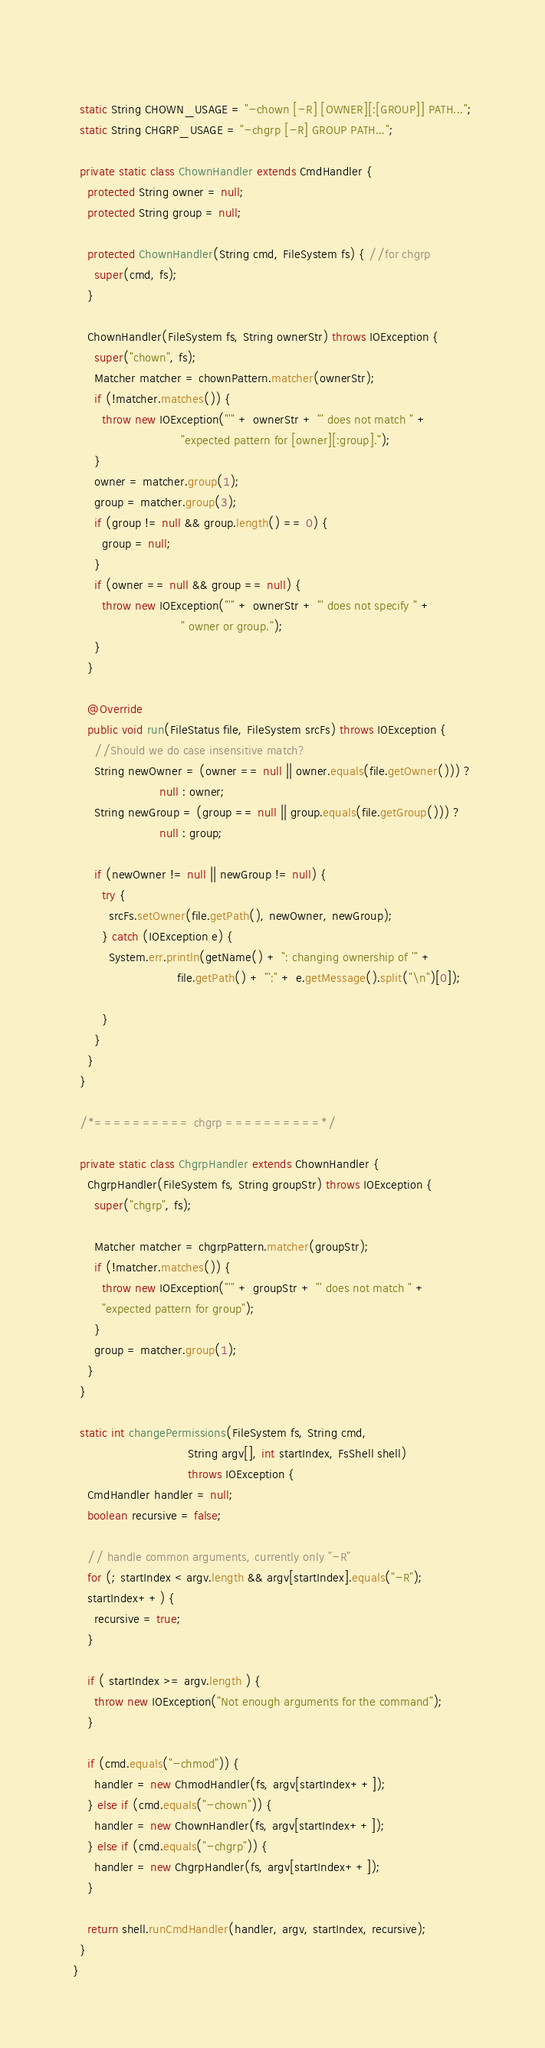<code> <loc_0><loc_0><loc_500><loc_500><_Java_>  
  static String CHOWN_USAGE = "-chown [-R] [OWNER][:[GROUP]] PATH...";
  static String CHGRP_USAGE = "-chgrp [-R] GROUP PATH...";  

  private static class ChownHandler extends CmdHandler {
    protected String owner = null;
    protected String group = null;

    protected ChownHandler(String cmd, FileSystem fs) { //for chgrp
      super(cmd, fs);
    }

    ChownHandler(FileSystem fs, String ownerStr) throws IOException {
      super("chown", fs);
      Matcher matcher = chownPattern.matcher(ownerStr);
      if (!matcher.matches()) {
        throw new IOException("'" + ownerStr + "' does not match " +
                              "expected pattern for [owner][:group].");
      }
      owner = matcher.group(1);
      group = matcher.group(3);
      if (group != null && group.length() == 0) {
        group = null;
      }
      if (owner == null && group == null) {
        throw new IOException("'" + ownerStr + "' does not specify " +
                              " owner or group.");
      }
    }

    @Override
    public void run(FileStatus file, FileSystem srcFs) throws IOException {
      //Should we do case insensitive match?  
      String newOwner = (owner == null || owner.equals(file.getOwner())) ?
                        null : owner;
      String newGroup = (group == null || group.equals(file.getGroup())) ?
                        null : group;

      if (newOwner != null || newGroup != null) {
        try {
          srcFs.setOwner(file.getPath(), newOwner, newGroup);
        } catch (IOException e) {
          System.err.println(getName() + ": changing ownership of '" + 
                             file.getPath() + "':" + e.getMessage().split("\n")[0]);

        }
      }
    }
  }

  /*========== chgrp ==========*/    
  
  private static class ChgrpHandler extends ChownHandler {
    ChgrpHandler(FileSystem fs, String groupStr) throws IOException {
      super("chgrp", fs);

      Matcher matcher = chgrpPattern.matcher(groupStr);
      if (!matcher.matches()) {
        throw new IOException("'" + groupStr + "' does not match " +
        "expected pattern for group");
      }
      group = matcher.group(1);
    }
  }

  static int changePermissions(FileSystem fs, String cmd, 
                                String argv[], int startIndex, FsShell shell)
                                throws IOException {
    CmdHandler handler = null;
    boolean recursive = false;

    // handle common arguments, currently only "-R" 
    for (; startIndex < argv.length && argv[startIndex].equals("-R"); 
    startIndex++) {
      recursive = true;
    }

    if ( startIndex >= argv.length ) {
      throw new IOException("Not enough arguments for the command");
    }

    if (cmd.equals("-chmod")) {
      handler = new ChmodHandler(fs, argv[startIndex++]);
    } else if (cmd.equals("-chown")) {
      handler = new ChownHandler(fs, argv[startIndex++]);
    } else if (cmd.equals("-chgrp")) {
      handler = new ChgrpHandler(fs, argv[startIndex++]);
    }

    return shell.runCmdHandler(handler, argv, startIndex, recursive);
  } 
}
</code> 